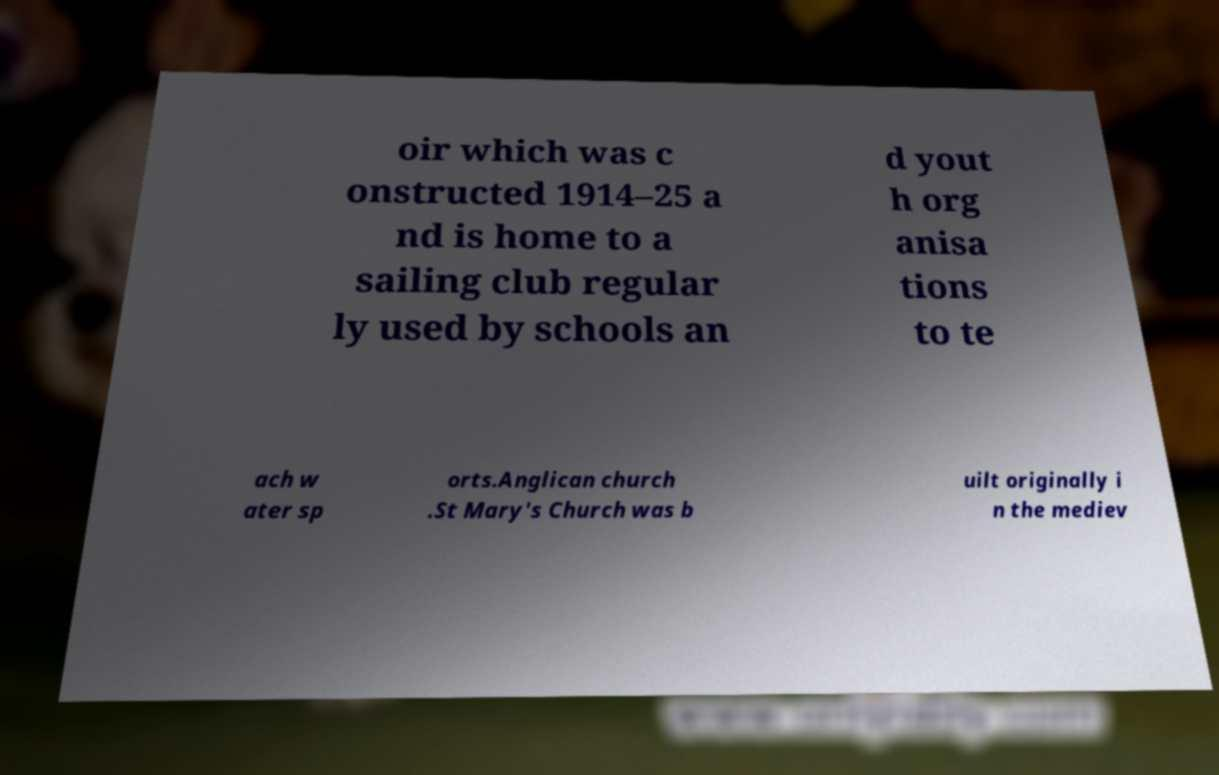Could you assist in decoding the text presented in this image and type it out clearly? oir which was c onstructed 1914–25 a nd is home to a sailing club regular ly used by schools an d yout h org anisa tions to te ach w ater sp orts.Anglican church .St Mary's Church was b uilt originally i n the mediev 